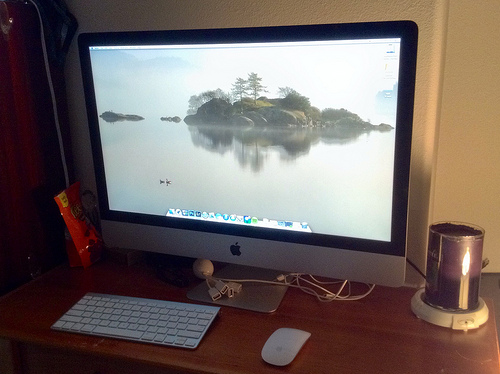<image>
Is the computer on the wall? No. The computer is not positioned on the wall. They may be near each other, but the computer is not supported by or resting on top of the wall. 